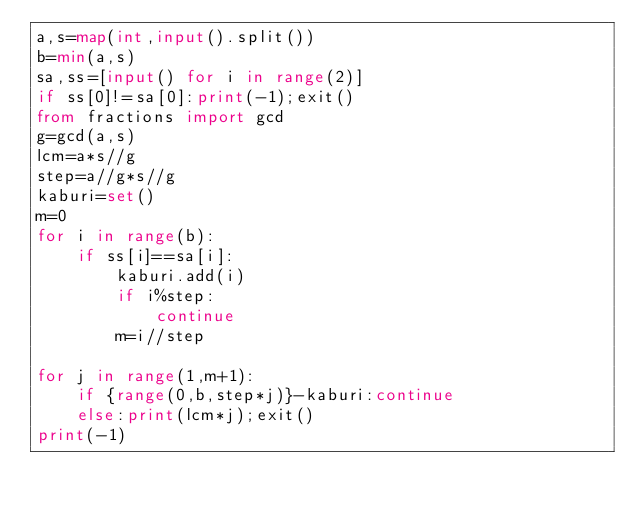<code> <loc_0><loc_0><loc_500><loc_500><_Python_>a,s=map(int,input().split())
b=min(a,s)
sa,ss=[input() for i in range(2)]
if ss[0]!=sa[0]:print(-1);exit()
from fractions import gcd
g=gcd(a,s)
lcm=a*s//g
step=a//g*s//g
kaburi=set()
m=0
for i in range(b):
    if ss[i]==sa[i]:
        kaburi.add(i)
        if i%step:
            continue
        m=i//step

for j in range(1,m+1):
    if {range(0,b,step*j)}-kaburi:continue
    else:print(lcm*j);exit()
print(-1)</code> 